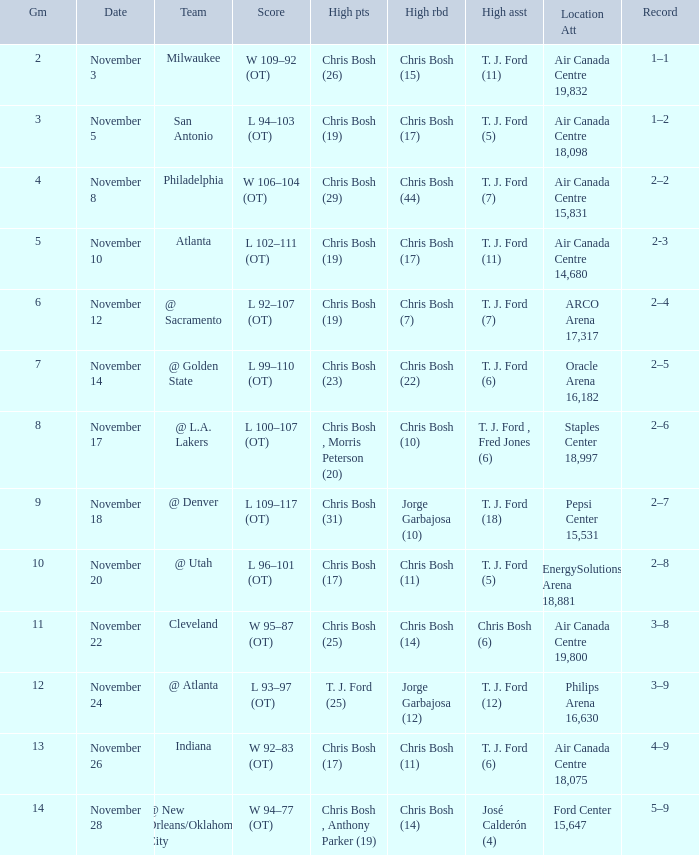Where was the game on November 20? EnergySolutions Arena 18,881. 